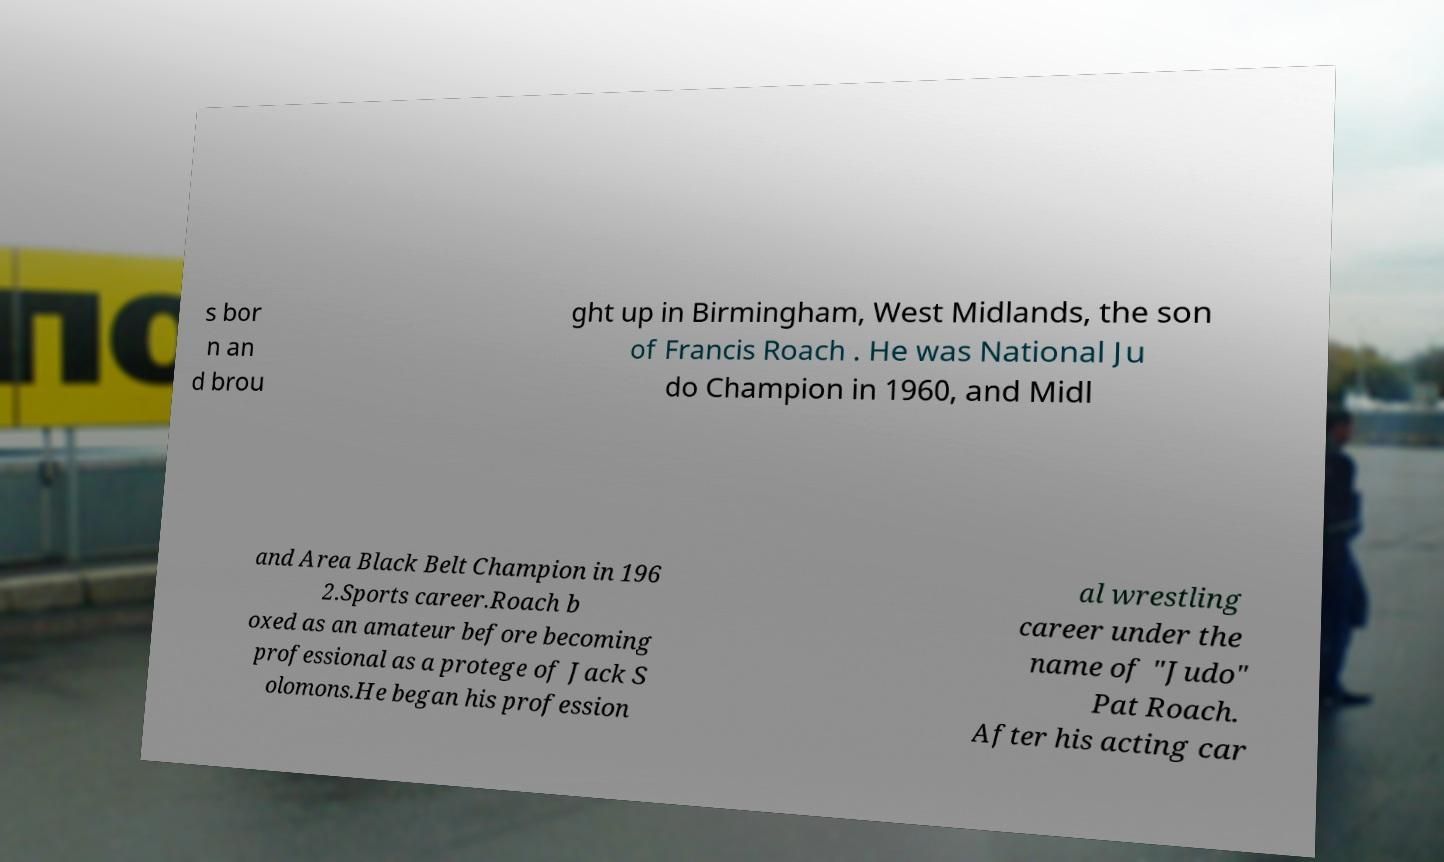Can you read and provide the text displayed in the image?This photo seems to have some interesting text. Can you extract and type it out for me? s bor n an d brou ght up in Birmingham, West Midlands, the son of Francis Roach . He was National Ju do Champion in 1960, and Midl and Area Black Belt Champion in 196 2.Sports career.Roach b oxed as an amateur before becoming professional as a protege of Jack S olomons.He began his profession al wrestling career under the name of "Judo" Pat Roach. After his acting car 